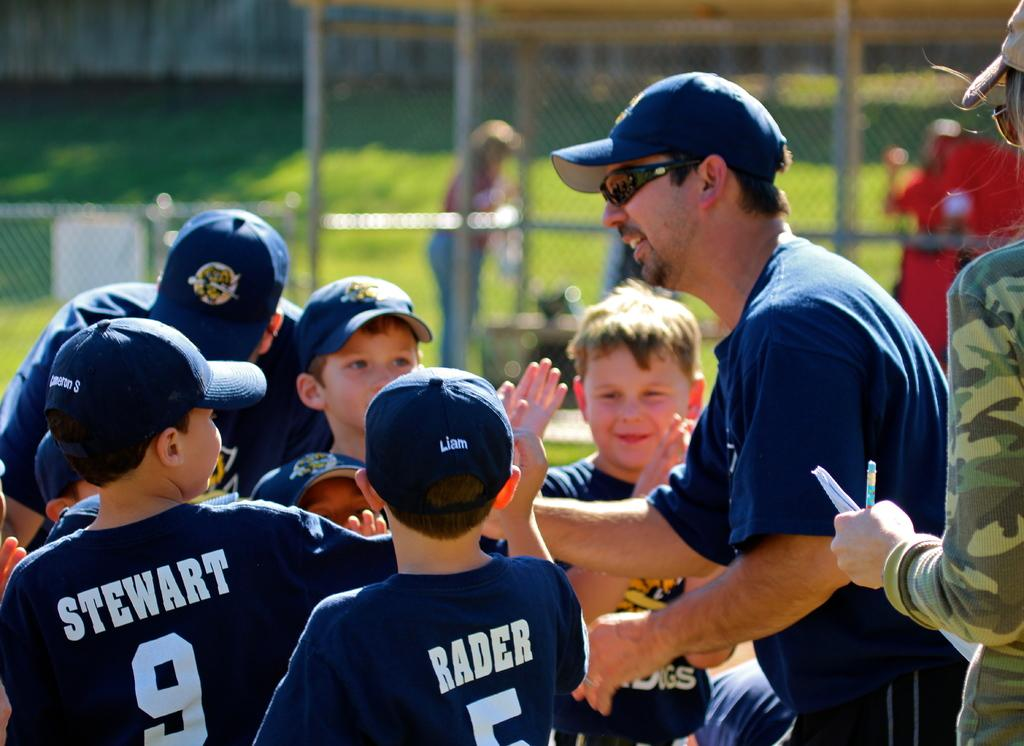<image>
Summarize the visual content of the image. Rader and Stewart getting ready to celebrate with their baseball team. 